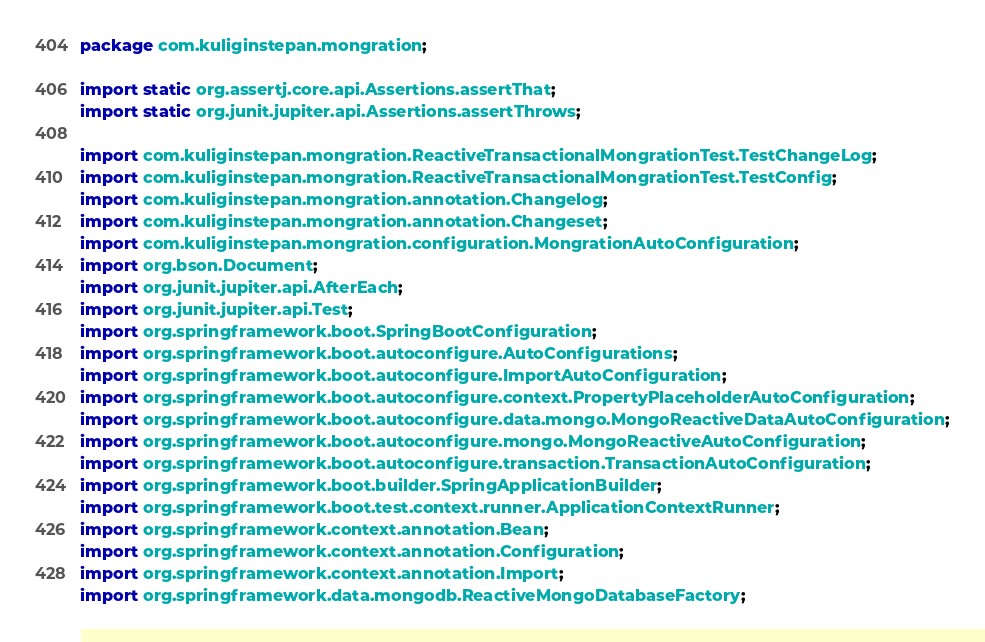<code> <loc_0><loc_0><loc_500><loc_500><_Java_>package com.kuliginstepan.mongration;

import static org.assertj.core.api.Assertions.assertThat;
import static org.junit.jupiter.api.Assertions.assertThrows;

import com.kuliginstepan.mongration.ReactiveTransactionalMongrationTest.TestChangeLog;
import com.kuliginstepan.mongration.ReactiveTransactionalMongrationTest.TestConfig;
import com.kuliginstepan.mongration.annotation.Changelog;
import com.kuliginstepan.mongration.annotation.Changeset;
import com.kuliginstepan.mongration.configuration.MongrationAutoConfiguration;
import org.bson.Document;
import org.junit.jupiter.api.AfterEach;
import org.junit.jupiter.api.Test;
import org.springframework.boot.SpringBootConfiguration;
import org.springframework.boot.autoconfigure.AutoConfigurations;
import org.springframework.boot.autoconfigure.ImportAutoConfiguration;
import org.springframework.boot.autoconfigure.context.PropertyPlaceholderAutoConfiguration;
import org.springframework.boot.autoconfigure.data.mongo.MongoReactiveDataAutoConfiguration;
import org.springframework.boot.autoconfigure.mongo.MongoReactiveAutoConfiguration;
import org.springframework.boot.autoconfigure.transaction.TransactionAutoConfiguration;
import org.springframework.boot.builder.SpringApplicationBuilder;
import org.springframework.boot.test.context.runner.ApplicationContextRunner;
import org.springframework.context.annotation.Bean;
import org.springframework.context.annotation.Configuration;
import org.springframework.context.annotation.Import;
import org.springframework.data.mongodb.ReactiveMongoDatabaseFactory;</code> 